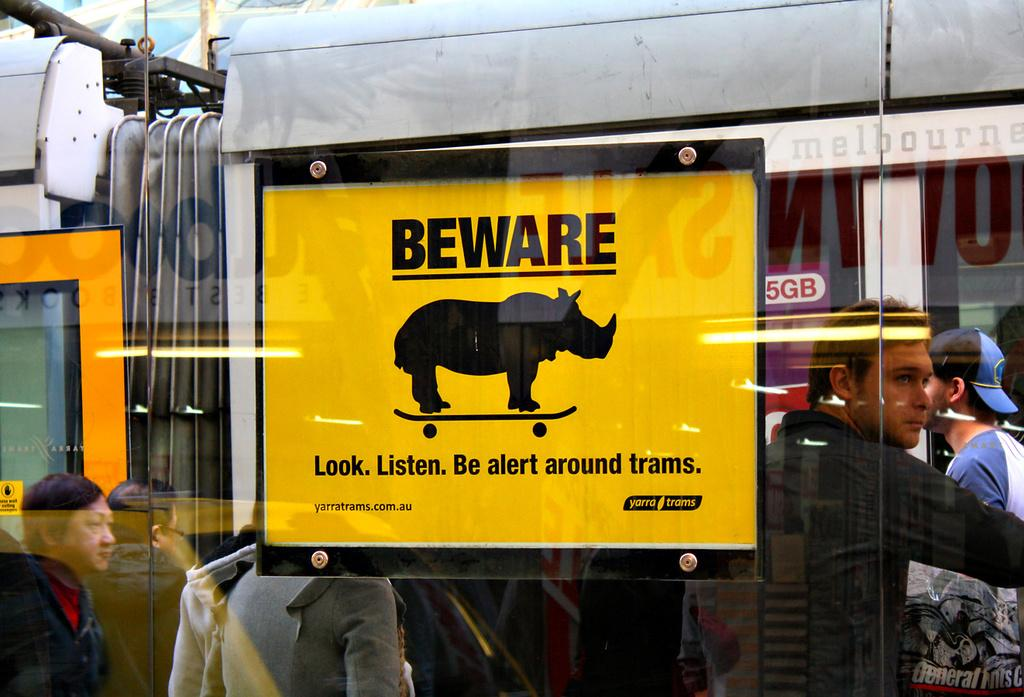What is featured on the board in the image? There is a board with text in the image. What is the medium of the picture on the glass window? The picture on the glass window is visible in the image. Can you describe the people visible on the backside of the image? There is a group of people visible on the backside of the image. What type of development or invention is taking place in the image? There is no indication of any development or invention in the image; it features a board with text, a picture on a glass window, and a group of people. How much dust can be seen on the board in the image? There is no mention of dust in the image, and it is not possible to determine its presence based on the provided facts. 